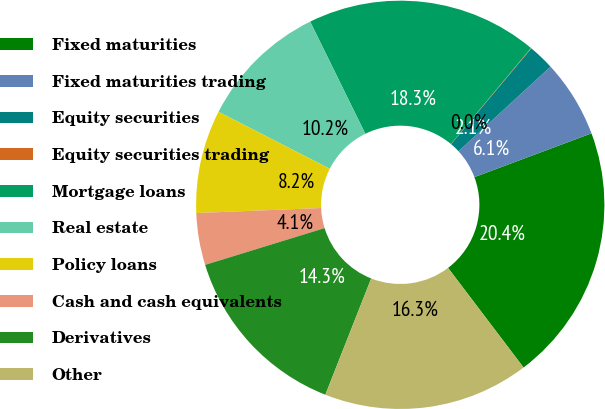Convert chart. <chart><loc_0><loc_0><loc_500><loc_500><pie_chart><fcel>Fixed maturities<fcel>Fixed maturities trading<fcel>Equity securities<fcel>Equity securities trading<fcel>Mortgage loans<fcel>Real estate<fcel>Policy loans<fcel>Cash and cash equivalents<fcel>Derivatives<fcel>Other<nl><fcel>20.37%<fcel>6.14%<fcel>2.07%<fcel>0.04%<fcel>18.33%<fcel>10.2%<fcel>8.17%<fcel>4.11%<fcel>14.27%<fcel>16.3%<nl></chart> 